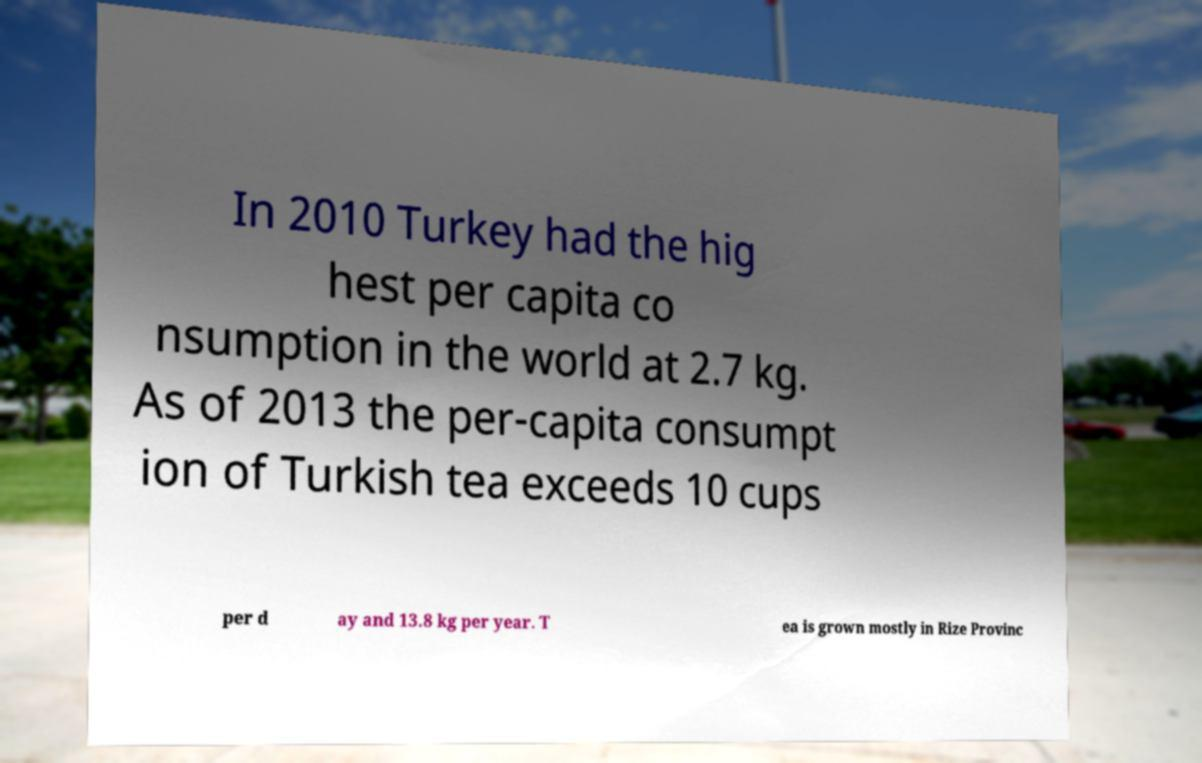Can you read and provide the text displayed in the image?This photo seems to have some interesting text. Can you extract and type it out for me? In 2010 Turkey had the hig hest per capita co nsumption in the world at 2.7 kg. As of 2013 the per-capita consumpt ion of Turkish tea exceeds 10 cups per d ay and 13.8 kg per year. T ea is grown mostly in Rize Provinc 